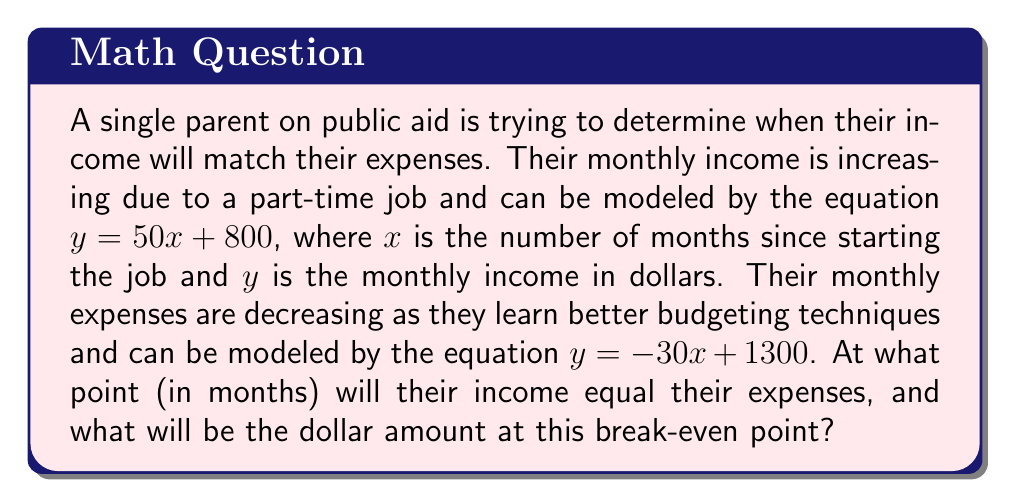What is the answer to this math problem? To find the intersection point of the income and expenses lines, we need to solve the system of equations:

Income: $y = 50x + 800$
Expenses: $y = -30x + 1300$

At the intersection point, the $y$ values (dollar amounts) will be equal for both equations. So we can set them equal to each other:

$$50x + 800 = -30x + 1300$$

Now, let's solve for $x$:

1) Add $30x$ to both sides:
   $$80x + 800 = 1300$$

2) Subtract 800 from both sides:
   $$80x = 500$$

3) Divide both sides by 80:
   $$x = \frac{500}{80} = 6.25$$

This means the break-even point occurs at 6.25 months.

To find the dollar amount at this point, we can substitute $x = 6.25$ into either of the original equations. Let's use the income equation:

$$y = 50(6.25) + 800 = 312.5 + 800 = 1112.5$$

Therefore, the break-even point occurs at 6.25 months with a dollar amount of $1112.50.

[asy]
import graph;
size(200,200);
real f(real x) {return 50x + 800;}
real g(real x) {return -30x + 1300;}
draw(graph(f,0,10),blue);
draw(graph(g,0,10),red);
dot((6.25,1112.5));
label("Income",(-0.5,f(0)),W,blue);
label("Expenses",(10,g(10)),E,red);
label("Break-even point",(6.25,1112.5),NE);
xaxis("Months",arrow=Arrow);
yaxis("Dollars",arrow=Arrow);
[/asy]
Answer: The break-even point occurs at 6.25 months with a monthly income/expense of $1112.50. 